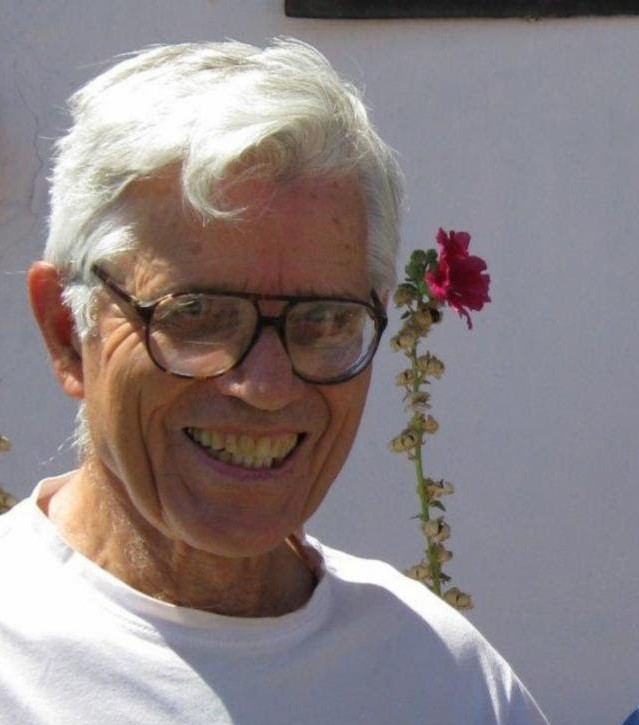What could the withered leaves and smaller flowers represent in a broader context? The withered leaves and smaller flowers on the stem could symbolize the passage of time and the natural cycle of life. In a broader context, they might represent the inevitable aging process, where youth and vibrancy gradually give way to maturity and senescence. This imagery can also reflect the beauty of life in all its stages, celebrating the fresh bloom while acknowledging the wisdom and experiences of the older parts. Can you elaborate on that symbolism in a more poetic manner? As the sunbeam caresses the crimson carnation, it whispers tales of fleeting seasons. The vibrant bloom, a testament to youth's fervor and life's ephemeral moments, graces the elder's crown. Yet, the withered leaves and fading blossoms along the stem sing a quieter song—a song of time's gentle touch, of memories etched in the patina of age. They tell a story of beauty transcending its prime, where the wisdom of past days intertwines with the spirited pulse of the present. In this delicate balance, the flower stands as a poignant reminder that every stage of life holds its own unique splendor, intertwined in the dance of existence. 